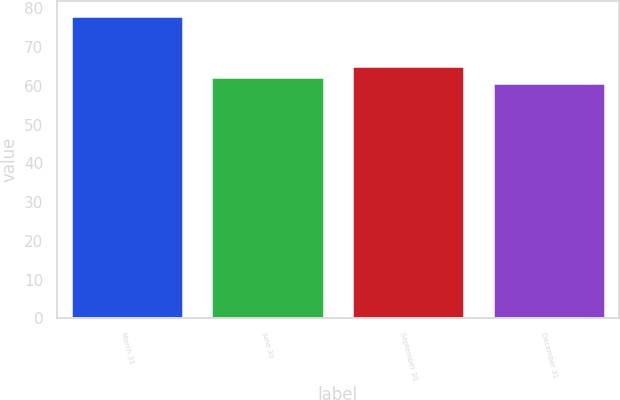<chart> <loc_0><loc_0><loc_500><loc_500><bar_chart><fcel>March 31<fcel>June 30<fcel>September 30<fcel>December 31<nl><fcel>78.1<fcel>62.37<fcel>65.03<fcel>60.62<nl></chart> 